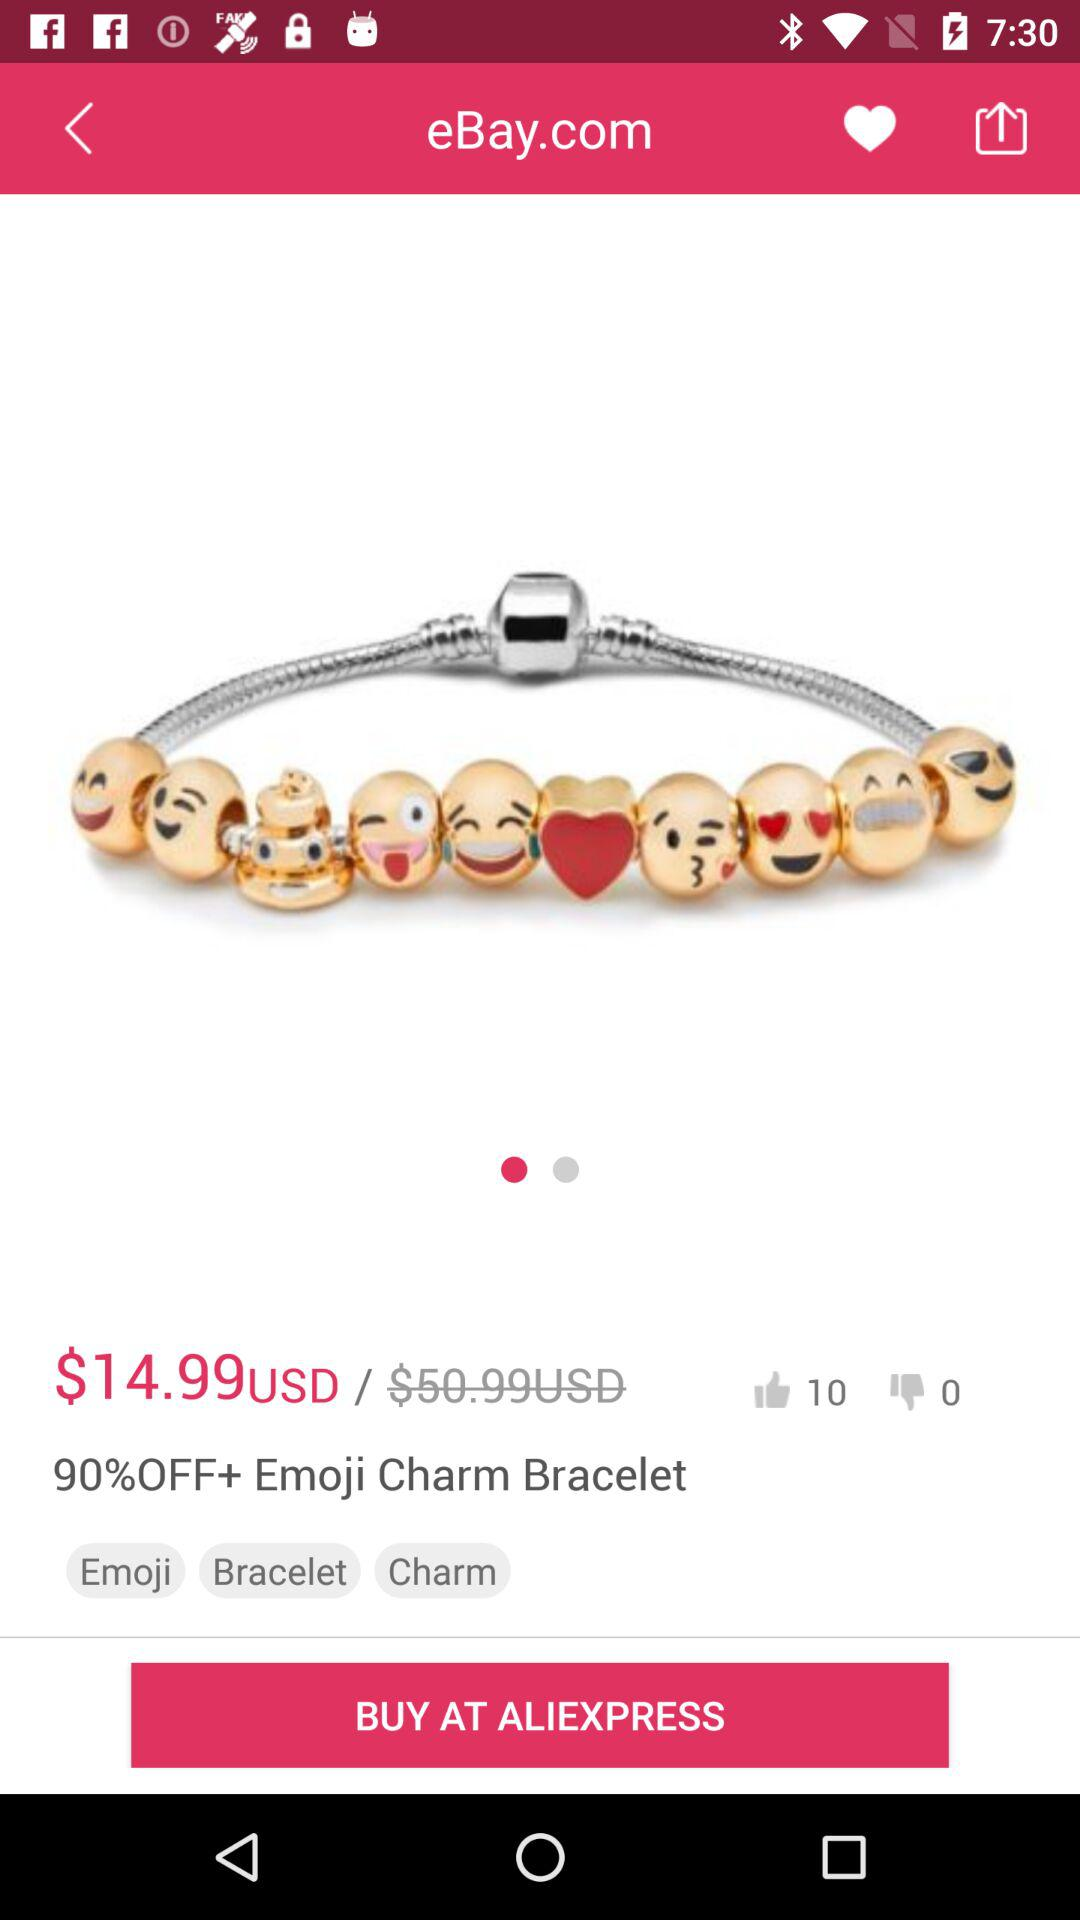How many people liked the "90%OFF+ Emoji Charm Bracelet"? The number of people who liked the "90%OFF+ Emoji Charm Bracelet" is 10. 